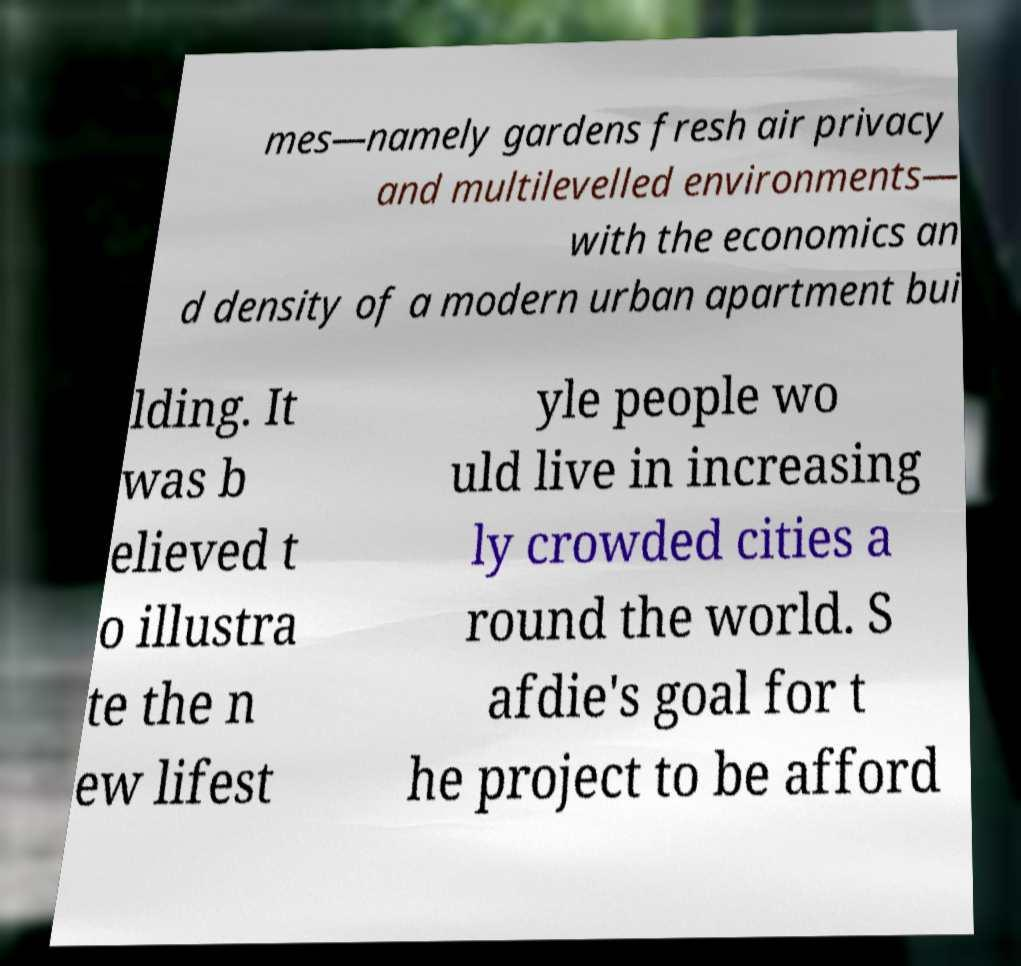There's text embedded in this image that I need extracted. Can you transcribe it verbatim? mes—namely gardens fresh air privacy and multilevelled environments— with the economics an d density of a modern urban apartment bui lding. It was b elieved t o illustra te the n ew lifest yle people wo uld live in increasing ly crowded cities a round the world. S afdie's goal for t he project to be afford 